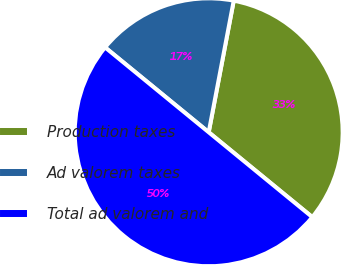Convert chart. <chart><loc_0><loc_0><loc_500><loc_500><pie_chart><fcel>Production taxes<fcel>Ad valorem taxes<fcel>Total ad valorem and<nl><fcel>32.93%<fcel>17.07%<fcel>50.0%<nl></chart> 